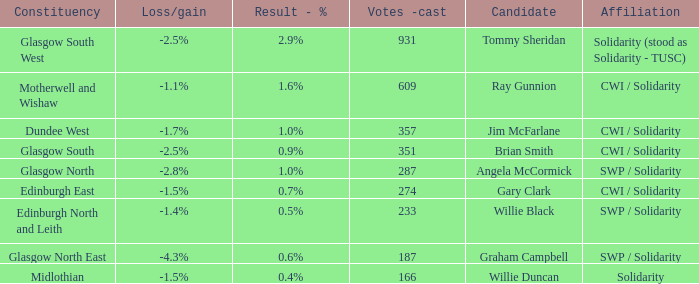What was the loss/gain when the affiliation was solidarity? -1.5%. 